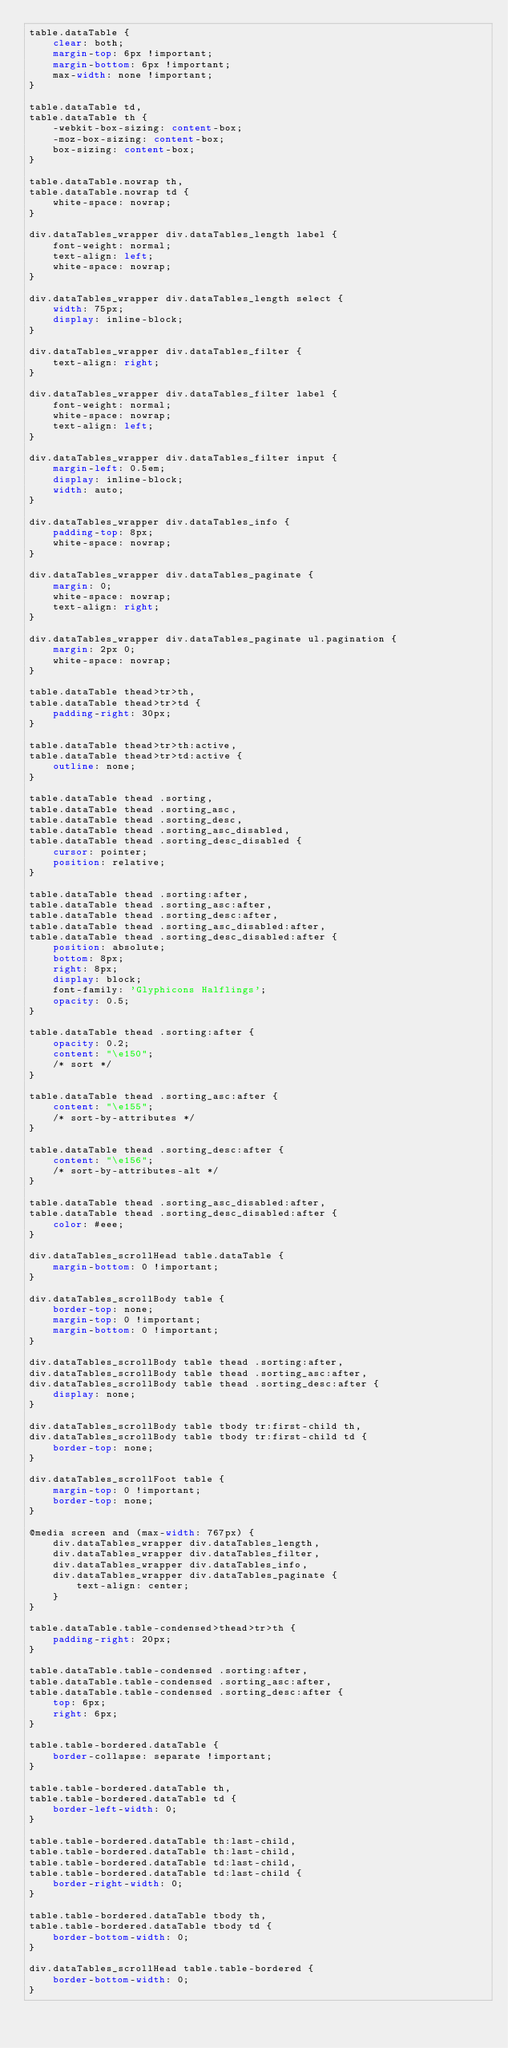Convert code to text. <code><loc_0><loc_0><loc_500><loc_500><_CSS_>table.dataTable {
    clear: both;
    margin-top: 6px !important;
    margin-bottom: 6px !important;
    max-width: none !important;
}

table.dataTable td,
table.dataTable th {
    -webkit-box-sizing: content-box;
    -moz-box-sizing: content-box;
    box-sizing: content-box;
}

table.dataTable.nowrap th,
table.dataTable.nowrap td {
    white-space: nowrap;
}

div.dataTables_wrapper div.dataTables_length label {
    font-weight: normal;
    text-align: left;
    white-space: nowrap;
}

div.dataTables_wrapper div.dataTables_length select {
    width: 75px;
    display: inline-block;
}

div.dataTables_wrapper div.dataTables_filter {
    text-align: right;
}

div.dataTables_wrapper div.dataTables_filter label {
    font-weight: normal;
    white-space: nowrap;
    text-align: left;
}

div.dataTables_wrapper div.dataTables_filter input {
    margin-left: 0.5em;
    display: inline-block;
    width: auto;
}

div.dataTables_wrapper div.dataTables_info {
    padding-top: 8px;
    white-space: nowrap;
}

div.dataTables_wrapper div.dataTables_paginate {
    margin: 0;
    white-space: nowrap;
    text-align: right;
}

div.dataTables_wrapper div.dataTables_paginate ul.pagination {
    margin: 2px 0;
    white-space: nowrap;
}

table.dataTable thead>tr>th,
table.dataTable thead>tr>td {
    padding-right: 30px;
}

table.dataTable thead>tr>th:active,
table.dataTable thead>tr>td:active {
    outline: none;
}

table.dataTable thead .sorting,
table.dataTable thead .sorting_asc,
table.dataTable thead .sorting_desc,
table.dataTable thead .sorting_asc_disabled,
table.dataTable thead .sorting_desc_disabled {
    cursor: pointer;
    position: relative;
}

table.dataTable thead .sorting:after,
table.dataTable thead .sorting_asc:after,
table.dataTable thead .sorting_desc:after,
table.dataTable thead .sorting_asc_disabled:after,
table.dataTable thead .sorting_desc_disabled:after {
    position: absolute;
    bottom: 8px;
    right: 8px;
    display: block;
    font-family: 'Glyphicons Halflings';
    opacity: 0.5;
}

table.dataTable thead .sorting:after {
    opacity: 0.2;
    content: "\e150";
    /* sort */
}

table.dataTable thead .sorting_asc:after {
    content: "\e155";
    /* sort-by-attributes */
}

table.dataTable thead .sorting_desc:after {
    content: "\e156";
    /* sort-by-attributes-alt */
}

table.dataTable thead .sorting_asc_disabled:after,
table.dataTable thead .sorting_desc_disabled:after {
    color: #eee;
}

div.dataTables_scrollHead table.dataTable {
    margin-bottom: 0 !important;
}

div.dataTables_scrollBody table {
    border-top: none;
    margin-top: 0 !important;
    margin-bottom: 0 !important;
}

div.dataTables_scrollBody table thead .sorting:after,
div.dataTables_scrollBody table thead .sorting_asc:after,
div.dataTables_scrollBody table thead .sorting_desc:after {
    display: none;
}

div.dataTables_scrollBody table tbody tr:first-child th,
div.dataTables_scrollBody table tbody tr:first-child td {
    border-top: none;
}

div.dataTables_scrollFoot table {
    margin-top: 0 !important;
    border-top: none;
}

@media screen and (max-width: 767px) {
    div.dataTables_wrapper div.dataTables_length,
    div.dataTables_wrapper div.dataTables_filter,
    div.dataTables_wrapper div.dataTables_info,
    div.dataTables_wrapper div.dataTables_paginate {
        text-align: center;
    }
}

table.dataTable.table-condensed>thead>tr>th {
    padding-right: 20px;
}

table.dataTable.table-condensed .sorting:after,
table.dataTable.table-condensed .sorting_asc:after,
table.dataTable.table-condensed .sorting_desc:after {
    top: 6px;
    right: 6px;
}

table.table-bordered.dataTable {
    border-collapse: separate !important;
}

table.table-bordered.dataTable th,
table.table-bordered.dataTable td {
    border-left-width: 0;
}

table.table-bordered.dataTable th:last-child,
table.table-bordered.dataTable th:last-child,
table.table-bordered.dataTable td:last-child,
table.table-bordered.dataTable td:last-child {
    border-right-width: 0;
}

table.table-bordered.dataTable tbody th,
table.table-bordered.dataTable tbody td {
    border-bottom-width: 0;
}

div.dataTables_scrollHead table.table-bordered {
    border-bottom-width: 0;
}</code> 